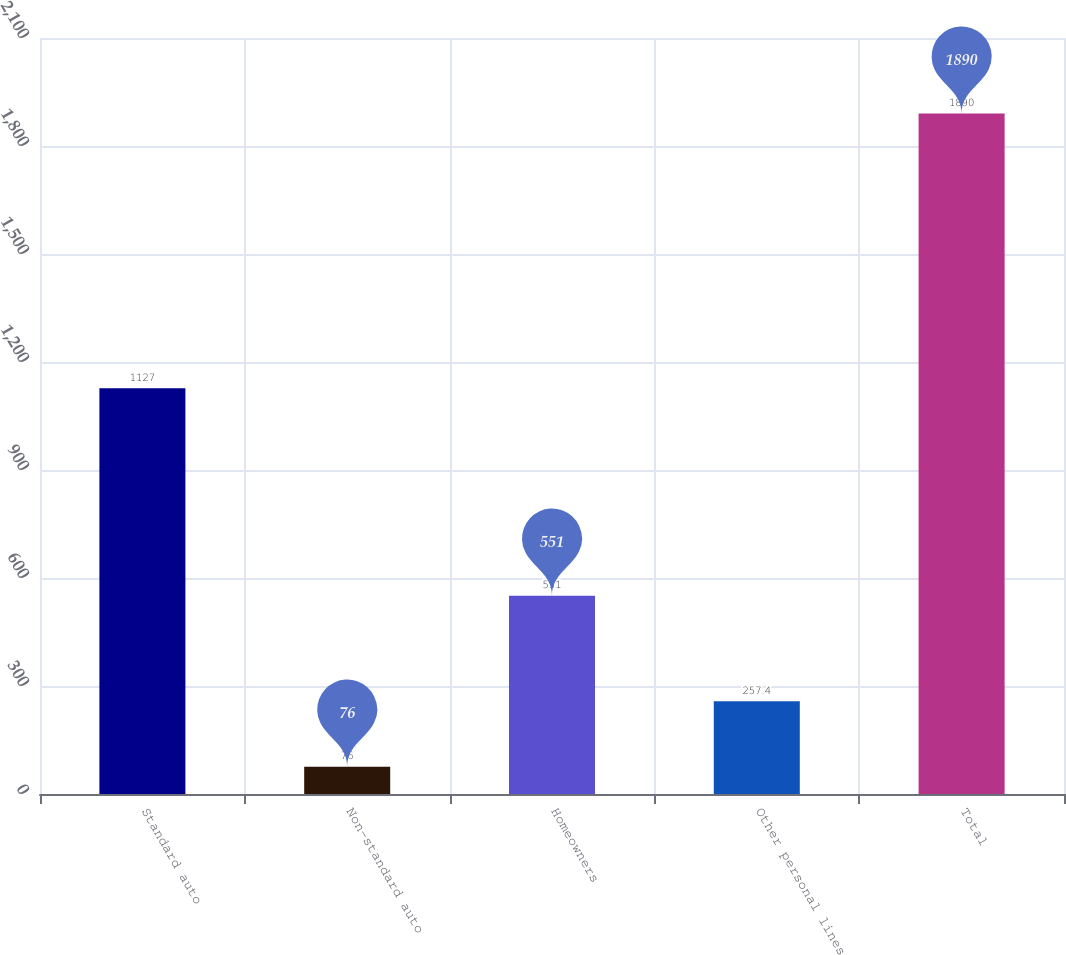Convert chart. <chart><loc_0><loc_0><loc_500><loc_500><bar_chart><fcel>Standard auto<fcel>Non-standard auto<fcel>Homeowners<fcel>Other personal lines<fcel>Total<nl><fcel>1127<fcel>76<fcel>551<fcel>257.4<fcel>1890<nl></chart> 